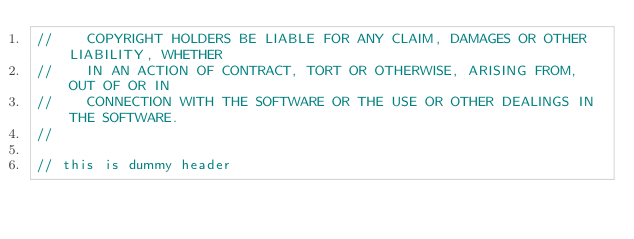<code> <loc_0><loc_0><loc_500><loc_500><_C_>//    COPYRIGHT HOLDERS BE LIABLE FOR ANY CLAIM, DAMAGES OR OTHER LIABILITY, WHETHER
//    IN AN ACTION OF CONTRACT, TORT OR OTHERWISE, ARISING FROM, OUT OF OR IN
//    CONNECTION WITH THE SOFTWARE OR THE USE OR OTHER DEALINGS IN THE SOFTWARE.
//

// this is dummy header
</code> 